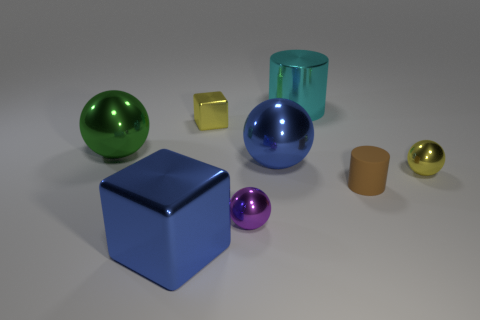Add 1 large blue spheres. How many objects exist? 9 Subtract all green spheres. Subtract all gray cylinders. How many spheres are left? 3 Subtract all large green rubber cylinders. Subtract all tiny purple metal things. How many objects are left? 7 Add 1 big green metal spheres. How many big green metal spheres are left? 2 Add 5 green spheres. How many green spheres exist? 6 Subtract 1 yellow cubes. How many objects are left? 7 Subtract all cylinders. How many objects are left? 6 